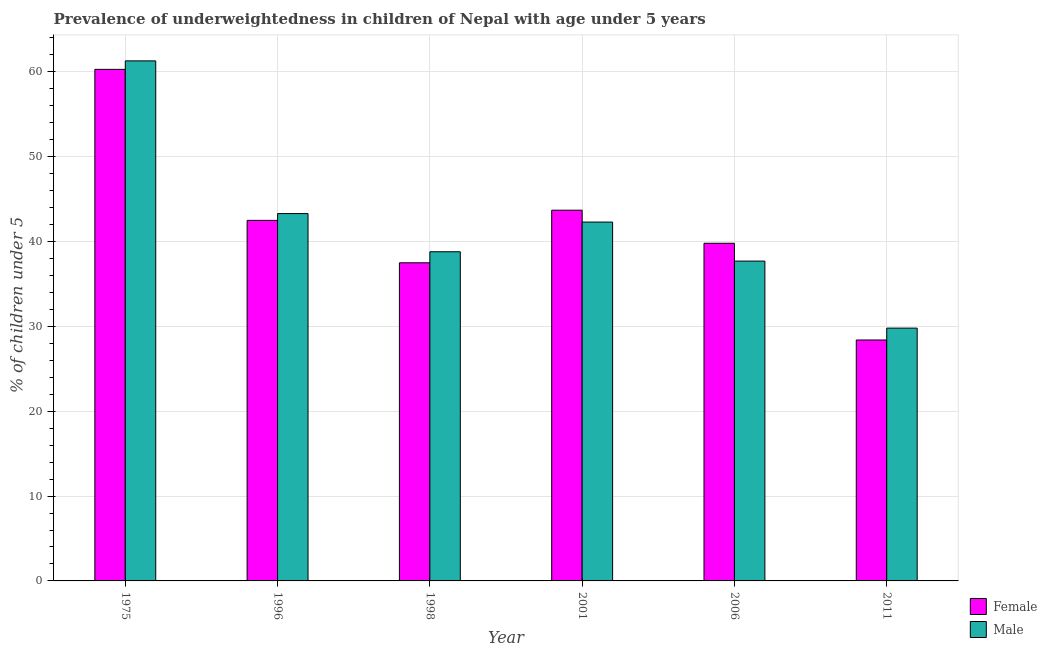Are the number of bars per tick equal to the number of legend labels?
Offer a very short reply. Yes. Are the number of bars on each tick of the X-axis equal?
Your answer should be very brief. Yes. How many bars are there on the 3rd tick from the left?
Your answer should be compact. 2. How many bars are there on the 2nd tick from the right?
Keep it short and to the point. 2. In how many cases, is the number of bars for a given year not equal to the number of legend labels?
Your response must be concise. 0. What is the percentage of underweighted male children in 1998?
Your answer should be compact. 38.8. Across all years, what is the maximum percentage of underweighted male children?
Ensure brevity in your answer.  61.3. Across all years, what is the minimum percentage of underweighted female children?
Offer a terse response. 28.4. In which year was the percentage of underweighted female children maximum?
Provide a succinct answer. 1975. What is the total percentage of underweighted male children in the graph?
Provide a short and direct response. 253.2. What is the difference between the percentage of underweighted female children in 1975 and that in 2011?
Offer a very short reply. 31.9. What is the average percentage of underweighted male children per year?
Your answer should be compact. 42.2. In how many years, is the percentage of underweighted male children greater than 34 %?
Provide a short and direct response. 5. What is the ratio of the percentage of underweighted male children in 1998 to that in 2011?
Make the answer very short. 1.3. What is the difference between the highest and the second highest percentage of underweighted female children?
Ensure brevity in your answer.  16.6. What is the difference between the highest and the lowest percentage of underweighted male children?
Provide a succinct answer. 31.5. Is the sum of the percentage of underweighted male children in 1998 and 2001 greater than the maximum percentage of underweighted female children across all years?
Offer a terse response. Yes. What does the 2nd bar from the right in 1996 represents?
Your answer should be very brief. Female. What is the difference between two consecutive major ticks on the Y-axis?
Provide a succinct answer. 10. Are the values on the major ticks of Y-axis written in scientific E-notation?
Offer a terse response. No. Where does the legend appear in the graph?
Your answer should be very brief. Bottom right. How many legend labels are there?
Offer a terse response. 2. How are the legend labels stacked?
Offer a terse response. Vertical. What is the title of the graph?
Give a very brief answer. Prevalence of underweightedness in children of Nepal with age under 5 years. Does "Research and Development" appear as one of the legend labels in the graph?
Provide a succinct answer. No. What is the label or title of the X-axis?
Your answer should be very brief. Year. What is the label or title of the Y-axis?
Provide a succinct answer.  % of children under 5. What is the  % of children under 5 in Female in 1975?
Keep it short and to the point. 60.3. What is the  % of children under 5 of Male in 1975?
Your answer should be compact. 61.3. What is the  % of children under 5 in Female in 1996?
Ensure brevity in your answer.  42.5. What is the  % of children under 5 of Male in 1996?
Give a very brief answer. 43.3. What is the  % of children under 5 in Female in 1998?
Your answer should be very brief. 37.5. What is the  % of children under 5 of Male in 1998?
Your answer should be very brief. 38.8. What is the  % of children under 5 of Female in 2001?
Make the answer very short. 43.7. What is the  % of children under 5 of Male in 2001?
Provide a succinct answer. 42.3. What is the  % of children under 5 in Female in 2006?
Offer a very short reply. 39.8. What is the  % of children under 5 of Male in 2006?
Keep it short and to the point. 37.7. What is the  % of children under 5 in Female in 2011?
Make the answer very short. 28.4. What is the  % of children under 5 of Male in 2011?
Your answer should be compact. 29.8. Across all years, what is the maximum  % of children under 5 in Female?
Provide a short and direct response. 60.3. Across all years, what is the maximum  % of children under 5 of Male?
Ensure brevity in your answer.  61.3. Across all years, what is the minimum  % of children under 5 in Female?
Ensure brevity in your answer.  28.4. Across all years, what is the minimum  % of children under 5 of Male?
Keep it short and to the point. 29.8. What is the total  % of children under 5 of Female in the graph?
Provide a short and direct response. 252.2. What is the total  % of children under 5 of Male in the graph?
Offer a terse response. 253.2. What is the difference between the  % of children under 5 of Female in 1975 and that in 1998?
Provide a succinct answer. 22.8. What is the difference between the  % of children under 5 of Male in 1975 and that in 2006?
Provide a succinct answer. 23.6. What is the difference between the  % of children under 5 of Female in 1975 and that in 2011?
Ensure brevity in your answer.  31.9. What is the difference between the  % of children under 5 of Male in 1975 and that in 2011?
Provide a short and direct response. 31.5. What is the difference between the  % of children under 5 of Female in 1996 and that in 1998?
Offer a terse response. 5. What is the difference between the  % of children under 5 in Male in 1996 and that in 2001?
Your answer should be very brief. 1. What is the difference between the  % of children under 5 of Male in 1996 and that in 2006?
Give a very brief answer. 5.6. What is the difference between the  % of children under 5 in Female in 1998 and that in 2001?
Give a very brief answer. -6.2. What is the difference between the  % of children under 5 in Male in 1998 and that in 2001?
Give a very brief answer. -3.5. What is the difference between the  % of children under 5 of Female in 1998 and that in 2011?
Make the answer very short. 9.1. What is the difference between the  % of children under 5 in Male in 1998 and that in 2011?
Your answer should be compact. 9. What is the difference between the  % of children under 5 in Female in 2001 and that in 2011?
Give a very brief answer. 15.3. What is the difference between the  % of children under 5 in Female in 2006 and that in 2011?
Give a very brief answer. 11.4. What is the difference between the  % of children under 5 of Female in 1975 and the  % of children under 5 of Male in 2001?
Your answer should be very brief. 18. What is the difference between the  % of children under 5 in Female in 1975 and the  % of children under 5 in Male in 2006?
Keep it short and to the point. 22.6. What is the difference between the  % of children under 5 in Female in 1975 and the  % of children under 5 in Male in 2011?
Make the answer very short. 30.5. What is the difference between the  % of children under 5 of Female in 1998 and the  % of children under 5 of Male in 2006?
Your answer should be very brief. -0.2. What is the difference between the  % of children under 5 of Female in 1998 and the  % of children under 5 of Male in 2011?
Make the answer very short. 7.7. What is the difference between the  % of children under 5 in Female in 2001 and the  % of children under 5 in Male in 2006?
Your answer should be very brief. 6. What is the difference between the  % of children under 5 in Female in 2001 and the  % of children under 5 in Male in 2011?
Offer a very short reply. 13.9. What is the difference between the  % of children under 5 of Female in 2006 and the  % of children under 5 of Male in 2011?
Provide a short and direct response. 10. What is the average  % of children under 5 of Female per year?
Your response must be concise. 42.03. What is the average  % of children under 5 of Male per year?
Your answer should be compact. 42.2. In the year 1975, what is the difference between the  % of children under 5 in Female and  % of children under 5 in Male?
Your answer should be very brief. -1. In the year 1996, what is the difference between the  % of children under 5 of Female and  % of children under 5 of Male?
Your response must be concise. -0.8. In the year 1998, what is the difference between the  % of children under 5 in Female and  % of children under 5 in Male?
Your response must be concise. -1.3. In the year 2011, what is the difference between the  % of children under 5 of Female and  % of children under 5 of Male?
Provide a succinct answer. -1.4. What is the ratio of the  % of children under 5 in Female in 1975 to that in 1996?
Ensure brevity in your answer.  1.42. What is the ratio of the  % of children under 5 in Male in 1975 to that in 1996?
Keep it short and to the point. 1.42. What is the ratio of the  % of children under 5 in Female in 1975 to that in 1998?
Keep it short and to the point. 1.61. What is the ratio of the  % of children under 5 in Male in 1975 to that in 1998?
Give a very brief answer. 1.58. What is the ratio of the  % of children under 5 of Female in 1975 to that in 2001?
Make the answer very short. 1.38. What is the ratio of the  % of children under 5 of Male in 1975 to that in 2001?
Your answer should be very brief. 1.45. What is the ratio of the  % of children under 5 of Female in 1975 to that in 2006?
Your answer should be compact. 1.52. What is the ratio of the  % of children under 5 of Male in 1975 to that in 2006?
Make the answer very short. 1.63. What is the ratio of the  % of children under 5 in Female in 1975 to that in 2011?
Your answer should be compact. 2.12. What is the ratio of the  % of children under 5 of Male in 1975 to that in 2011?
Your answer should be very brief. 2.06. What is the ratio of the  % of children under 5 in Female in 1996 to that in 1998?
Give a very brief answer. 1.13. What is the ratio of the  % of children under 5 in Male in 1996 to that in 1998?
Give a very brief answer. 1.12. What is the ratio of the  % of children under 5 in Female in 1996 to that in 2001?
Make the answer very short. 0.97. What is the ratio of the  % of children under 5 of Male in 1996 to that in 2001?
Make the answer very short. 1.02. What is the ratio of the  % of children under 5 in Female in 1996 to that in 2006?
Provide a succinct answer. 1.07. What is the ratio of the  % of children under 5 in Male in 1996 to that in 2006?
Offer a terse response. 1.15. What is the ratio of the  % of children under 5 in Female in 1996 to that in 2011?
Your response must be concise. 1.5. What is the ratio of the  % of children under 5 in Male in 1996 to that in 2011?
Make the answer very short. 1.45. What is the ratio of the  % of children under 5 of Female in 1998 to that in 2001?
Ensure brevity in your answer.  0.86. What is the ratio of the  % of children under 5 of Male in 1998 to that in 2001?
Offer a very short reply. 0.92. What is the ratio of the  % of children under 5 in Female in 1998 to that in 2006?
Provide a short and direct response. 0.94. What is the ratio of the  % of children under 5 of Male in 1998 to that in 2006?
Your answer should be very brief. 1.03. What is the ratio of the  % of children under 5 in Female in 1998 to that in 2011?
Make the answer very short. 1.32. What is the ratio of the  % of children under 5 in Male in 1998 to that in 2011?
Your answer should be compact. 1.3. What is the ratio of the  % of children under 5 in Female in 2001 to that in 2006?
Your response must be concise. 1.1. What is the ratio of the  % of children under 5 of Male in 2001 to that in 2006?
Offer a terse response. 1.12. What is the ratio of the  % of children under 5 in Female in 2001 to that in 2011?
Provide a succinct answer. 1.54. What is the ratio of the  % of children under 5 in Male in 2001 to that in 2011?
Offer a terse response. 1.42. What is the ratio of the  % of children under 5 in Female in 2006 to that in 2011?
Offer a very short reply. 1.4. What is the ratio of the  % of children under 5 in Male in 2006 to that in 2011?
Your response must be concise. 1.27. What is the difference between the highest and the lowest  % of children under 5 of Female?
Make the answer very short. 31.9. What is the difference between the highest and the lowest  % of children under 5 in Male?
Give a very brief answer. 31.5. 